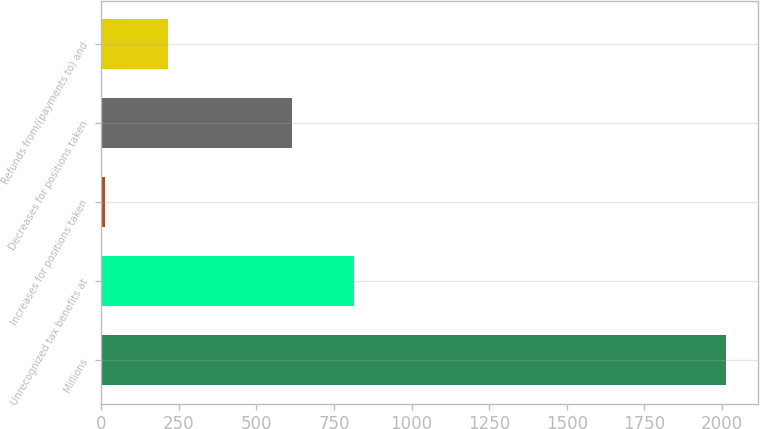<chart> <loc_0><loc_0><loc_500><loc_500><bar_chart><fcel>Millions<fcel>Unrecognized tax benefits at<fcel>Increases for positions taken<fcel>Decreases for positions taken<fcel>Refunds from/(payments to) and<nl><fcel>2015<fcel>813.8<fcel>13<fcel>613.6<fcel>213.2<nl></chart> 